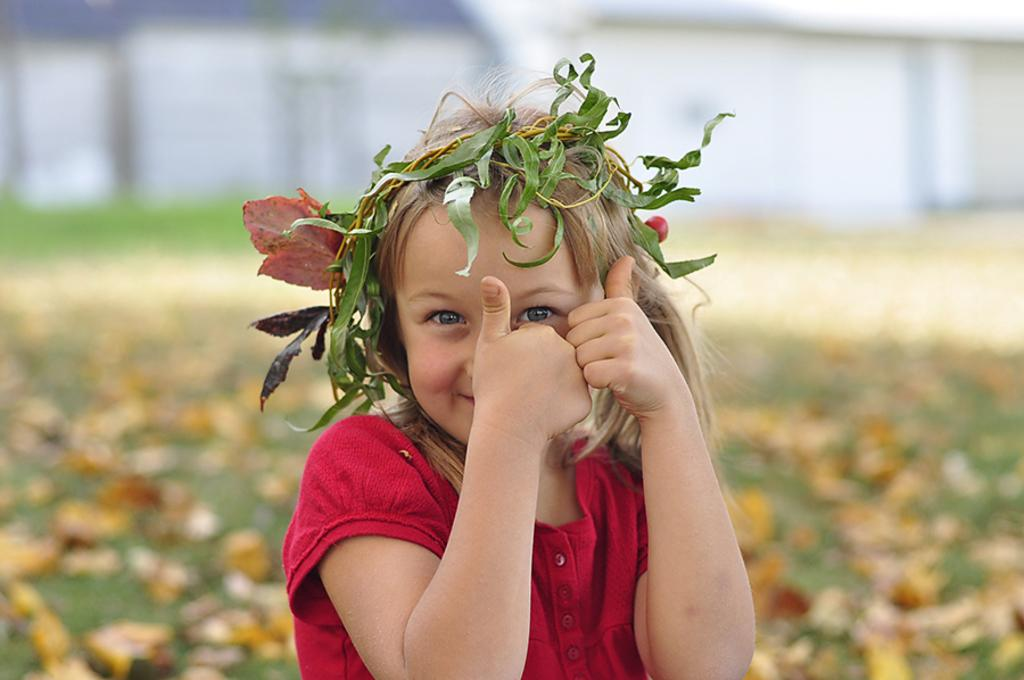Who is the main subject in the image? There is a small girl in the image. Where is the girl located in the image? The girl is in the center of the image. What is surrounding the girl's head in the image? There are leaves around the girl's head. What is the price of the amusement ride in the image? There is no amusement ride present in the image, so it is not possible to determine its price. 